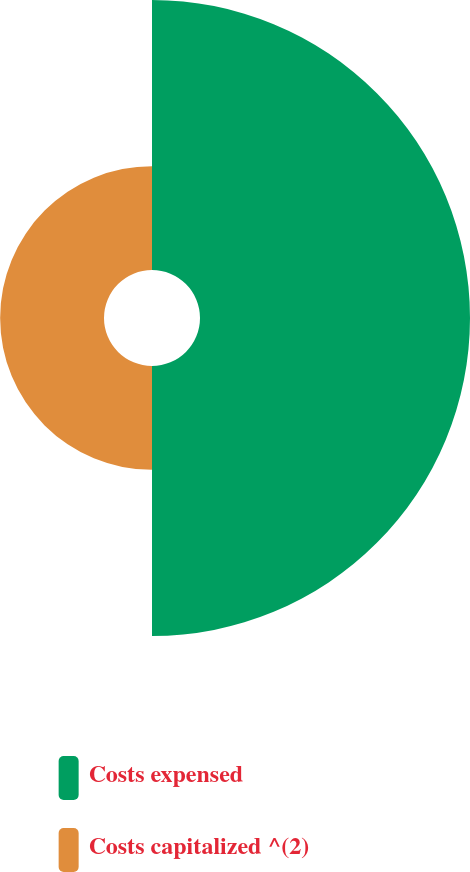Convert chart to OTSL. <chart><loc_0><loc_0><loc_500><loc_500><pie_chart><fcel>Costs expensed<fcel>Costs capitalized ^(2)<nl><fcel>72.22%<fcel>27.78%<nl></chart> 